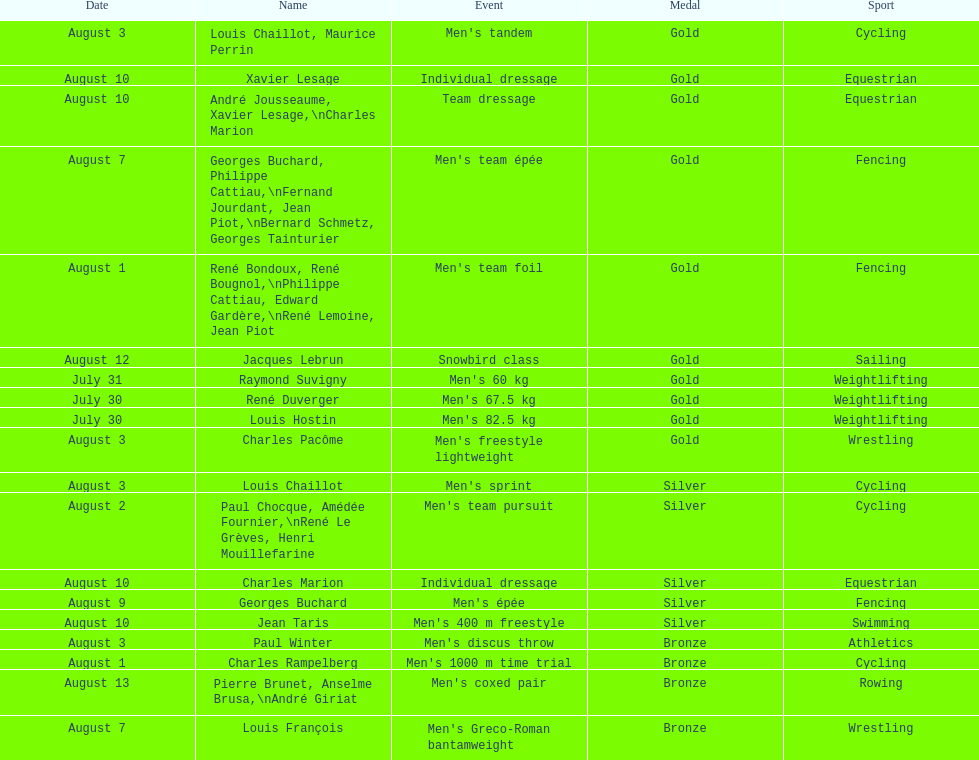Was there more gold medals won than silver? Yes. 